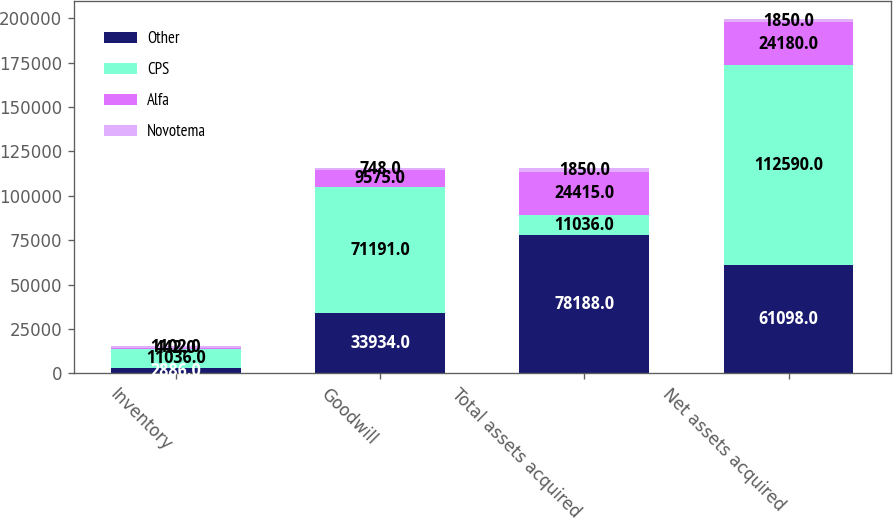Convert chart. <chart><loc_0><loc_0><loc_500><loc_500><stacked_bar_chart><ecel><fcel>Inventory<fcel>Goodwill<fcel>Total assets acquired<fcel>Net assets acquired<nl><fcel>Other<fcel>2886<fcel>33934<fcel>78188<fcel>61098<nl><fcel>CPS<fcel>11036<fcel>71191<fcel>11036<fcel>112590<nl><fcel>Alfa<fcel>442<fcel>9575<fcel>24415<fcel>24180<nl><fcel>Novotema<fcel>1102<fcel>748<fcel>1850<fcel>1850<nl></chart> 